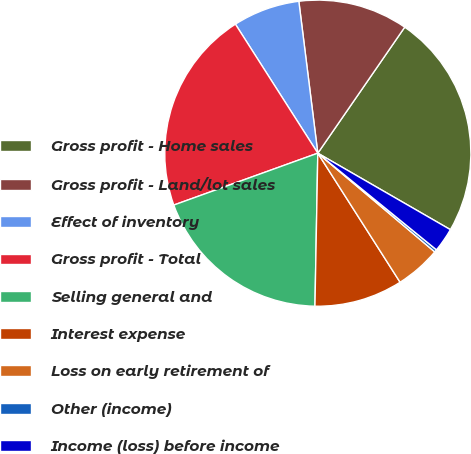Convert chart to OTSL. <chart><loc_0><loc_0><loc_500><loc_500><pie_chart><fcel>Gross profit - Home sales<fcel>Gross profit - Land/lot sales<fcel>Effect of inventory<fcel>Gross profit - Total<fcel>Selling general and<fcel>Interest expense<fcel>Loss on early retirement of<fcel>Other (income)<fcel>Income (loss) before income<nl><fcel>23.72%<fcel>11.59%<fcel>7.07%<fcel>21.46%<fcel>19.2%<fcel>9.33%<fcel>4.81%<fcel>0.28%<fcel>2.55%<nl></chart> 